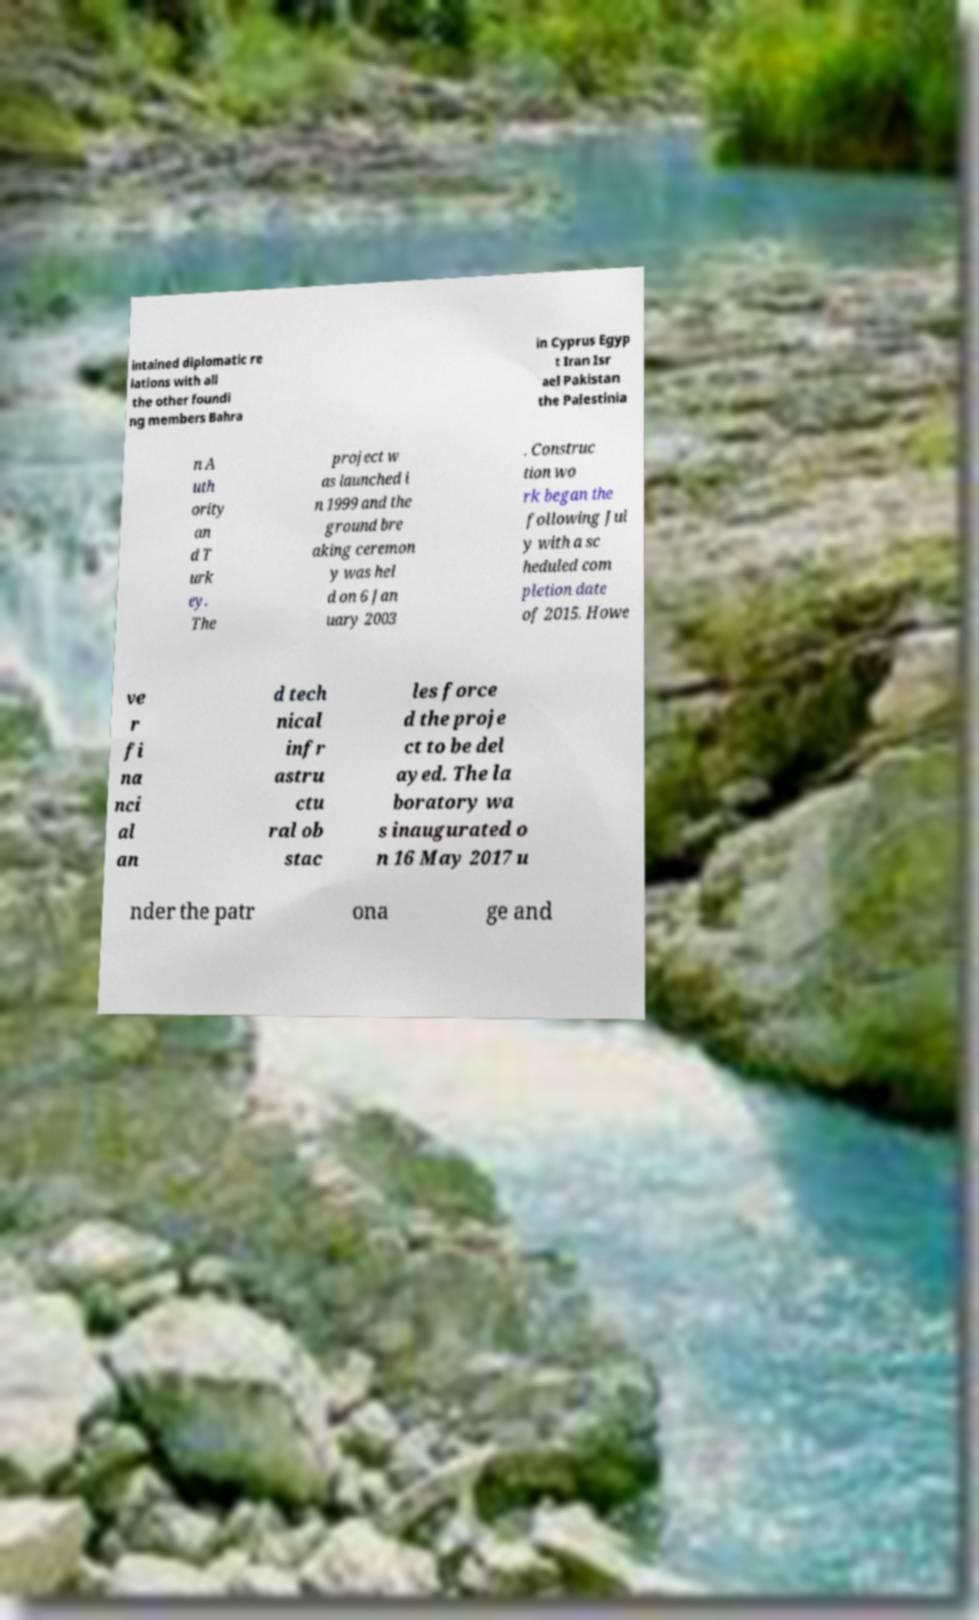Can you read and provide the text displayed in the image?This photo seems to have some interesting text. Can you extract and type it out for me? intained diplomatic re lations with all the other foundi ng members Bahra in Cyprus Egyp t Iran Isr ael Pakistan the Palestinia n A uth ority an d T urk ey. The project w as launched i n 1999 and the ground bre aking ceremon y was hel d on 6 Jan uary 2003 . Construc tion wo rk began the following Jul y with a sc heduled com pletion date of 2015. Howe ve r fi na nci al an d tech nical infr astru ctu ral ob stac les force d the proje ct to be del ayed. The la boratory wa s inaugurated o n 16 May 2017 u nder the patr ona ge and 